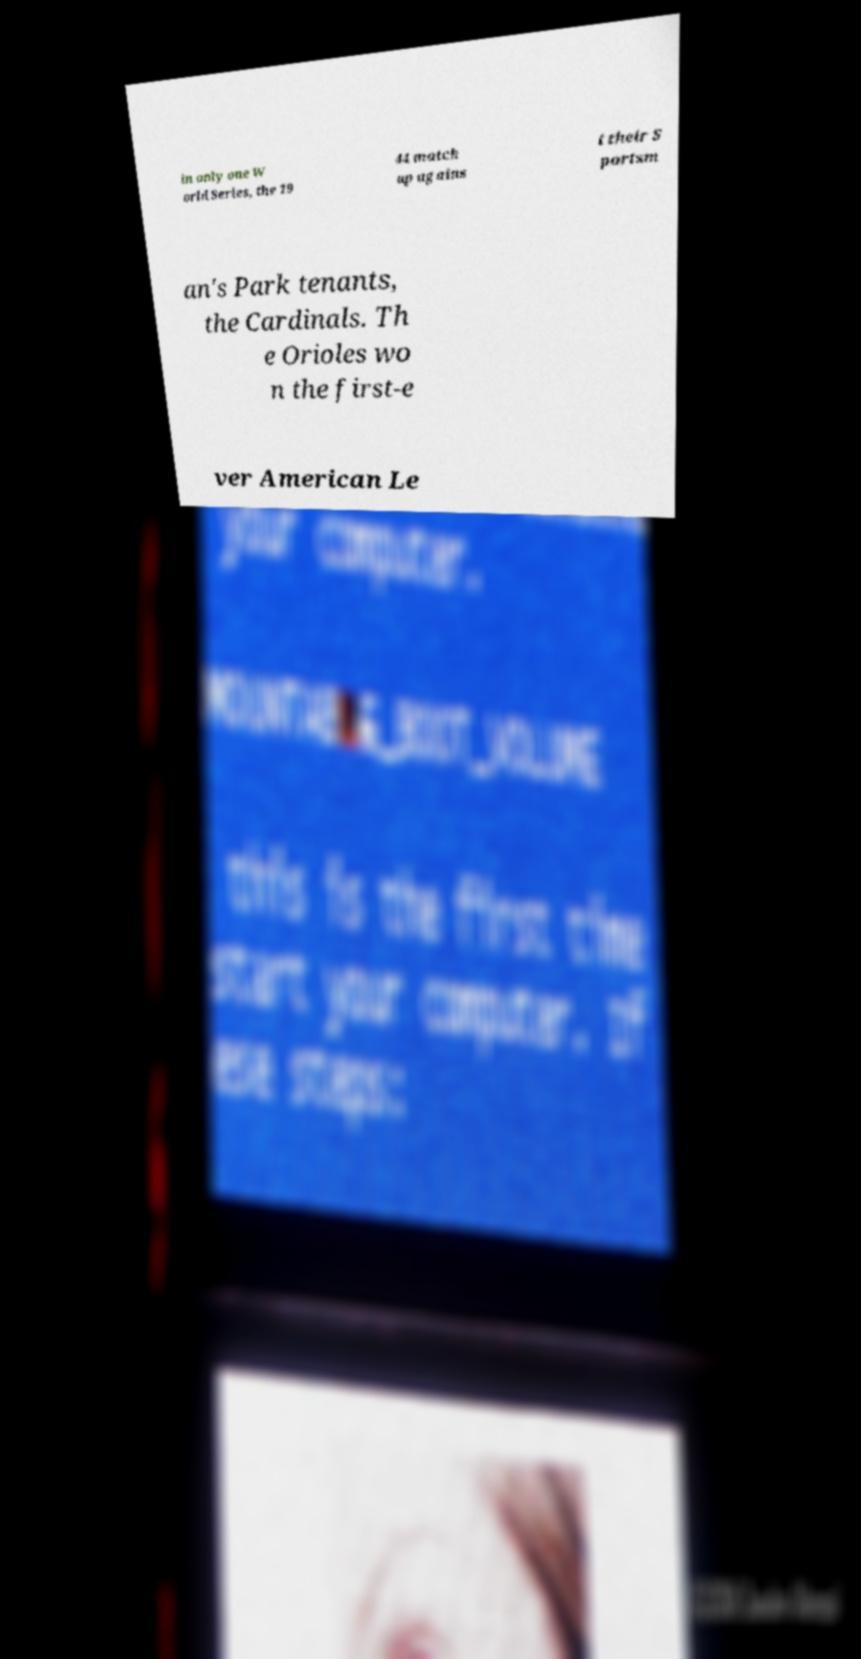Could you extract and type out the text from this image? in only one W orld Series, the 19 44 match up agains t their S portsm an's Park tenants, the Cardinals. Th e Orioles wo n the first-e ver American Le 